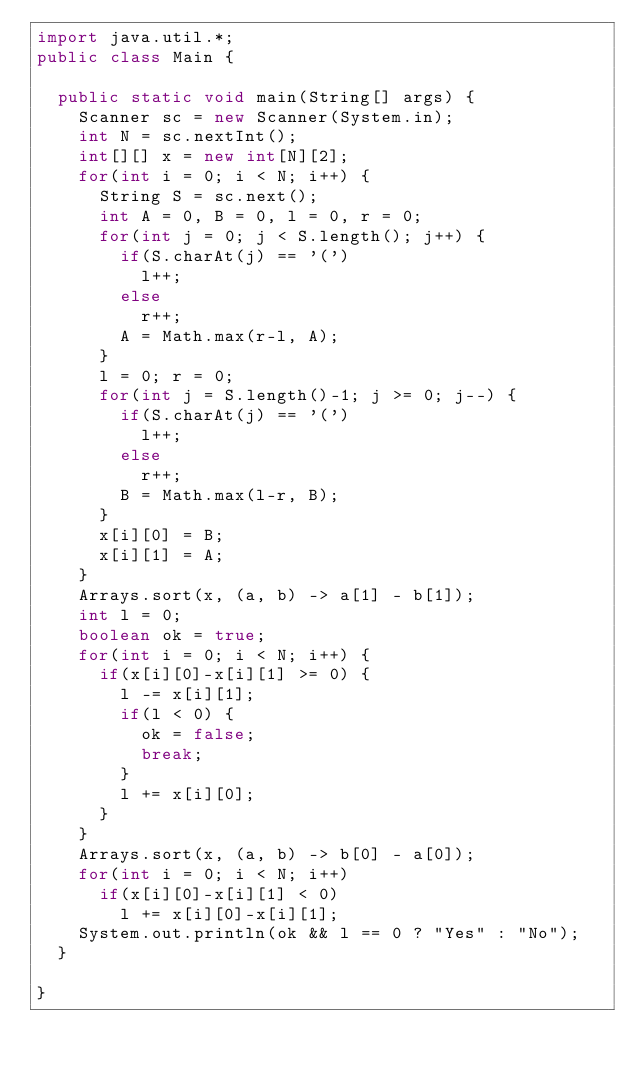<code> <loc_0><loc_0><loc_500><loc_500><_Java_>import java.util.*;
public class Main {

	public static void main(String[] args) {
		Scanner sc = new Scanner(System.in);
		int N = sc.nextInt();
		int[][] x = new int[N][2];
		for(int i = 0; i < N; i++) {
			String S = sc.next();
			int A = 0, B = 0, l = 0, r = 0;
			for(int j = 0; j < S.length(); j++) {
				if(S.charAt(j) == '(')
					l++;
				else
					r++;
				A = Math.max(r-l, A);
			}
			l = 0; r = 0;
			for(int j = S.length()-1; j >= 0; j--) {
				if(S.charAt(j) == '(')
					l++;
				else
					r++;
				B = Math.max(l-r, B);
			}
			x[i][0] = B;
			x[i][1] = A;
		}
		Arrays.sort(x, (a, b) -> a[1] - b[1]);
		int l = 0;
		boolean ok = true;
		for(int i = 0; i < N; i++) {
			if(x[i][0]-x[i][1] >= 0) {
				l -= x[i][1];
				if(l < 0) {
					ok = false;
					break;
				}
				l += x[i][0];
			}
		}
		Arrays.sort(x, (a, b) -> b[0] - a[0]);
		for(int i = 0; i < N; i++)
			if(x[i][0]-x[i][1] < 0)
				l += x[i][0]-x[i][1];
		System.out.println(ok && l == 0 ? "Yes" : "No");
	}

}
</code> 